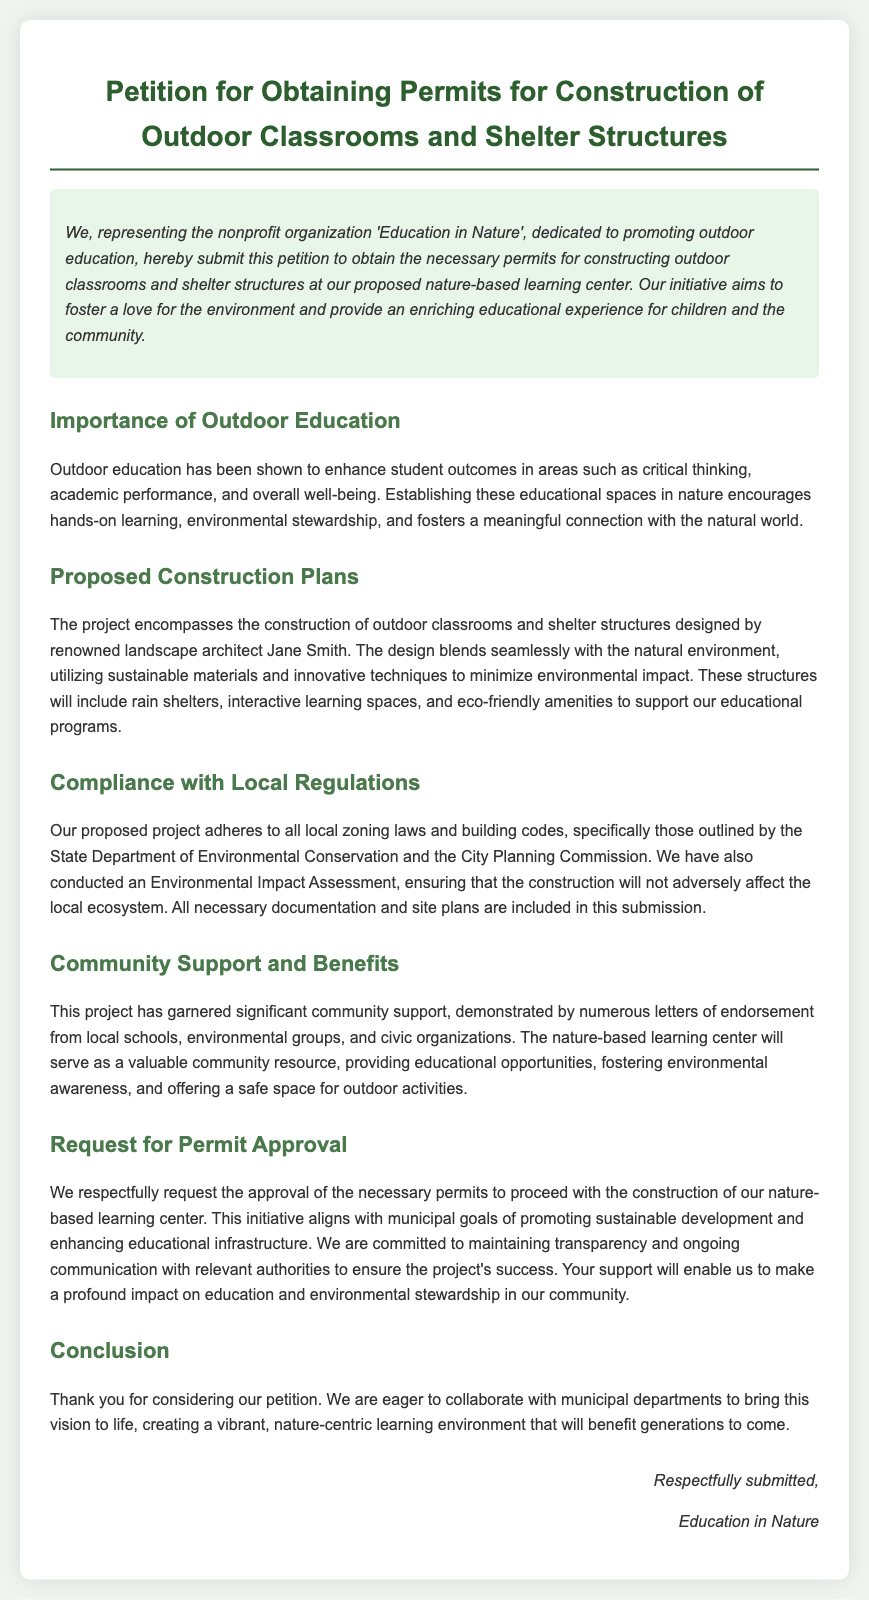What is the name of the nonprofit organization? The document mentions the nonprofit organization as "Education in Nature."
Answer: Education in Nature Who is the landscape architect for the project? The petition specifies that the design is by "renowned landscape architect Jane Smith."
Answer: Jane Smith What is the primary purpose of constructing the outdoor classrooms? The document states the purpose is to promote "outdoor education" and provide educational experiences.
Answer: outdoor education Which structures are included in the construction plans? The petition lists "rain shelters, interactive learning spaces, and eco-friendly amenities."
Answer: rain shelters, interactive learning spaces, and eco-friendly amenities What assessment was conducted to ensure environmental safety? The document indicates that an "Environmental Impact Assessment" was conducted.
Answer: Environmental Impact Assessment How does the project align with municipal goals? The proposal aligns with municipal goals of "promoting sustainable development and enhancing educational infrastructure."
Answer: promoting sustainable development and enhancing educational infrastructure What shows community support for the project? The petition highlights "numerous letters of endorsement" from various groups.
Answer: numerous letters of endorsement What type of permits are being requested? The document states the petition is for obtaining "necessary permits."
Answer: necessary permits What assurance is given regarding communication with authorities? The petition mentions a commitment to "maintaining transparency and ongoing communication."
Answer: maintaining transparency and ongoing communication 